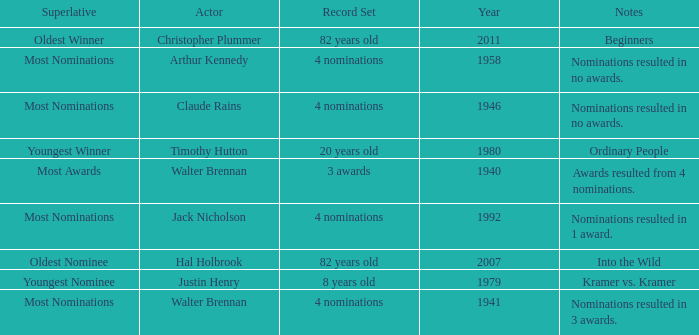What is the earliest year for ordinary people to appear in the notes? 1980.0. 